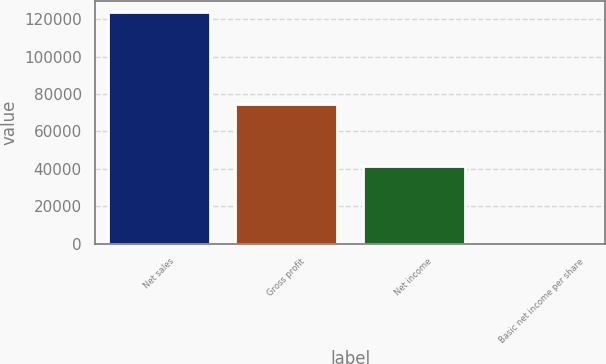Convert chart. <chart><loc_0><loc_0><loc_500><loc_500><bar_chart><fcel>Net sales<fcel>Gross profit<fcel>Net income<fcel>Basic net income per share<nl><fcel>123788<fcel>74655<fcel>41494<fcel>0.38<nl></chart> 